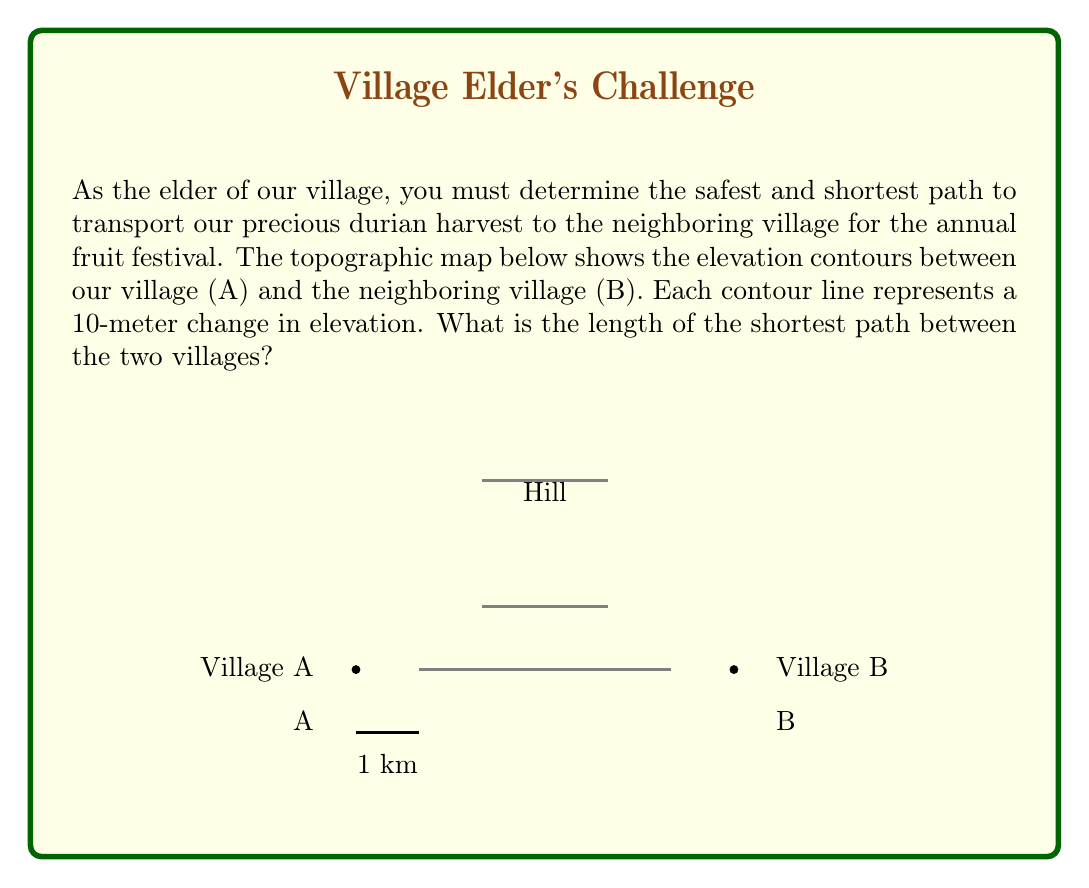Could you help me with this problem? To find the shortest path between the two villages, we need to consider the topography of the land. The straight-line distance would be the shortest in a flat plane, but the presence of a hill between the villages complicates the problem.

Step 1: Analyze the map
- The map shows a hill between villages A and B.
- Contour lines indicate that the hill reaches a maximum height of 30 meters above the villages.
- The scale shows that the straight-line distance between A and B is 6 km.

Step 2: Consider possible paths
1. Straight line over the hill
2. Path around the base of the hill

Step 3: Calculate the length of the straight-line path
- Using the Pythagorean theorem in 3D space:
$$d = \sqrt{6^2 + 0.03^2} \approx 6.000075 \text{ km}$$

Step 4: Calculate the length of the path around the hill
- Approximate the hill as a semicircle with radius 3 km
- The length of this path would be:
$$l = \pi r = \pi \cdot 3 \approx 9.42 \text{ km}$$

Step 5: Compare the two paths
The straight-line path (6.000075 km) is significantly shorter than the path around the hill (9.42 km).

Step 6: Consider practical factors
While the straight-line path is mathematically shorter, it may not be practically feasible due to the steepness of the hill. However, as the question asks for the shortest path, we must choose the straight-line option.
Answer: 6.000075 km 